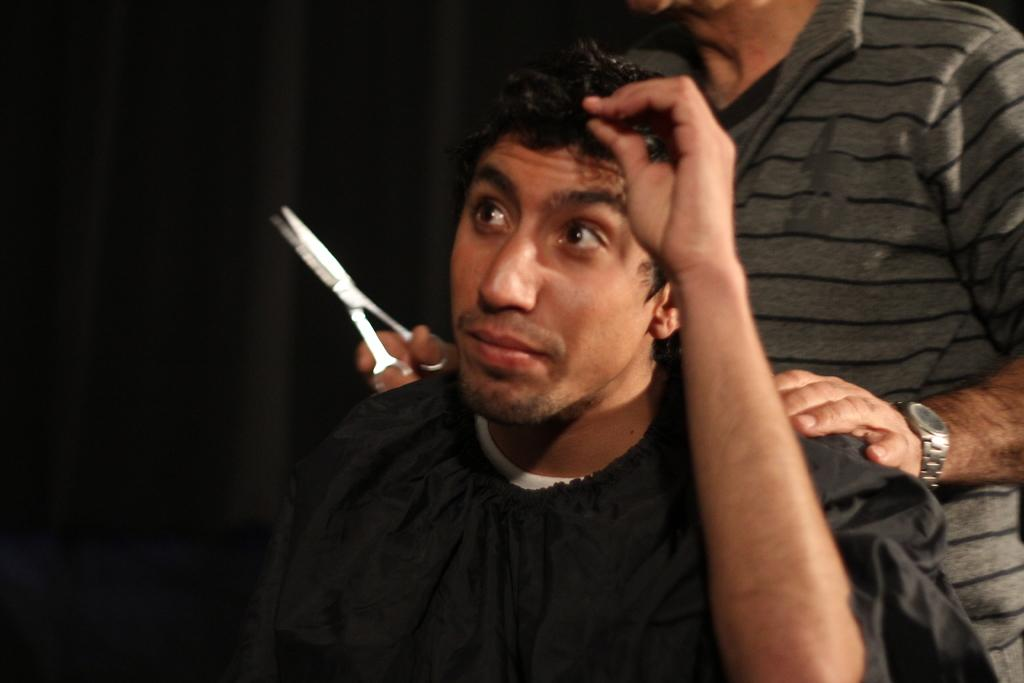How many people are in the image? There are two persons in the image. What is one person holding in the image? One person is holding scissors. What can be observed about the background of the image? The background of the image is dark. What type of bead is being used as a punishment in the image? There is no bead or punishment present in the image. What emotion might one of the persons be feeling based on the image? The image does not provide enough information to determine the emotions of the persons. 